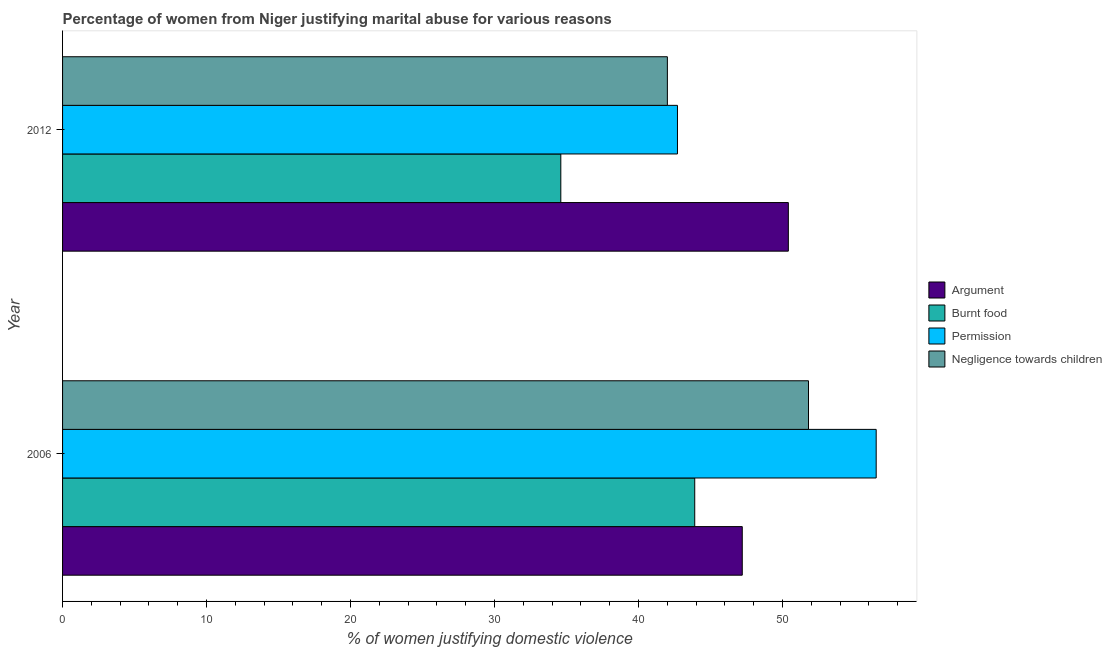How many different coloured bars are there?
Ensure brevity in your answer.  4. How many groups of bars are there?
Provide a short and direct response. 2. Are the number of bars per tick equal to the number of legend labels?
Your answer should be compact. Yes. What is the label of the 1st group of bars from the top?
Your response must be concise. 2012. What is the percentage of women justifying abuse for showing negligence towards children in 2006?
Your answer should be compact. 51.8. Across all years, what is the maximum percentage of women justifying abuse for going without permission?
Provide a succinct answer. 56.5. Across all years, what is the minimum percentage of women justifying abuse for going without permission?
Provide a short and direct response. 42.7. In which year was the percentage of women justifying abuse in the case of an argument maximum?
Ensure brevity in your answer.  2012. What is the total percentage of women justifying abuse for showing negligence towards children in the graph?
Provide a succinct answer. 93.8. What is the difference between the percentage of women justifying abuse for going without permission in 2006 and that in 2012?
Your answer should be very brief. 13.8. What is the difference between the percentage of women justifying abuse for showing negligence towards children in 2006 and the percentage of women justifying abuse for going without permission in 2012?
Ensure brevity in your answer.  9.1. What is the average percentage of women justifying abuse for burning food per year?
Give a very brief answer. 39.25. What is the ratio of the percentage of women justifying abuse for showing negligence towards children in 2006 to that in 2012?
Offer a terse response. 1.23. Is the percentage of women justifying abuse for burning food in 2006 less than that in 2012?
Offer a very short reply. No. In how many years, is the percentage of women justifying abuse for going without permission greater than the average percentage of women justifying abuse for going without permission taken over all years?
Provide a succinct answer. 1. Is it the case that in every year, the sum of the percentage of women justifying abuse for burning food and percentage of women justifying abuse in the case of an argument is greater than the sum of percentage of women justifying abuse for showing negligence towards children and percentage of women justifying abuse for going without permission?
Give a very brief answer. No. What does the 4th bar from the top in 2006 represents?
Your answer should be compact. Argument. What does the 2nd bar from the bottom in 2006 represents?
Provide a succinct answer. Burnt food. How many years are there in the graph?
Your answer should be very brief. 2. What is the difference between two consecutive major ticks on the X-axis?
Offer a terse response. 10. Are the values on the major ticks of X-axis written in scientific E-notation?
Offer a very short reply. No. Does the graph contain any zero values?
Offer a very short reply. No. Does the graph contain grids?
Make the answer very short. No. How many legend labels are there?
Give a very brief answer. 4. What is the title of the graph?
Make the answer very short. Percentage of women from Niger justifying marital abuse for various reasons. What is the label or title of the X-axis?
Offer a terse response. % of women justifying domestic violence. What is the % of women justifying domestic violence of Argument in 2006?
Give a very brief answer. 47.2. What is the % of women justifying domestic violence in Burnt food in 2006?
Your response must be concise. 43.9. What is the % of women justifying domestic violence in Permission in 2006?
Your response must be concise. 56.5. What is the % of women justifying domestic violence of Negligence towards children in 2006?
Make the answer very short. 51.8. What is the % of women justifying domestic violence in Argument in 2012?
Your response must be concise. 50.4. What is the % of women justifying domestic violence in Burnt food in 2012?
Your response must be concise. 34.6. What is the % of women justifying domestic violence in Permission in 2012?
Offer a very short reply. 42.7. What is the % of women justifying domestic violence of Negligence towards children in 2012?
Give a very brief answer. 42. Across all years, what is the maximum % of women justifying domestic violence in Argument?
Keep it short and to the point. 50.4. Across all years, what is the maximum % of women justifying domestic violence in Burnt food?
Provide a short and direct response. 43.9. Across all years, what is the maximum % of women justifying domestic violence of Permission?
Your answer should be very brief. 56.5. Across all years, what is the maximum % of women justifying domestic violence in Negligence towards children?
Your response must be concise. 51.8. Across all years, what is the minimum % of women justifying domestic violence of Argument?
Your answer should be very brief. 47.2. Across all years, what is the minimum % of women justifying domestic violence in Burnt food?
Give a very brief answer. 34.6. Across all years, what is the minimum % of women justifying domestic violence in Permission?
Make the answer very short. 42.7. What is the total % of women justifying domestic violence in Argument in the graph?
Your answer should be very brief. 97.6. What is the total % of women justifying domestic violence of Burnt food in the graph?
Your answer should be compact. 78.5. What is the total % of women justifying domestic violence of Permission in the graph?
Make the answer very short. 99.2. What is the total % of women justifying domestic violence in Negligence towards children in the graph?
Your response must be concise. 93.8. What is the difference between the % of women justifying domestic violence of Permission in 2006 and that in 2012?
Make the answer very short. 13.8. What is the difference between the % of women justifying domestic violence of Negligence towards children in 2006 and that in 2012?
Your answer should be compact. 9.8. What is the difference between the % of women justifying domestic violence in Argument in 2006 and the % of women justifying domestic violence in Permission in 2012?
Offer a terse response. 4.5. What is the difference between the % of women justifying domestic violence of Argument in 2006 and the % of women justifying domestic violence of Negligence towards children in 2012?
Your answer should be compact. 5.2. What is the difference between the % of women justifying domestic violence of Burnt food in 2006 and the % of women justifying domestic violence of Negligence towards children in 2012?
Make the answer very short. 1.9. What is the average % of women justifying domestic violence of Argument per year?
Make the answer very short. 48.8. What is the average % of women justifying domestic violence of Burnt food per year?
Provide a succinct answer. 39.25. What is the average % of women justifying domestic violence of Permission per year?
Offer a terse response. 49.6. What is the average % of women justifying domestic violence of Negligence towards children per year?
Your answer should be very brief. 46.9. In the year 2006, what is the difference between the % of women justifying domestic violence of Argument and % of women justifying domestic violence of Negligence towards children?
Offer a terse response. -4.6. In the year 2006, what is the difference between the % of women justifying domestic violence in Burnt food and % of women justifying domestic violence in Permission?
Your answer should be very brief. -12.6. In the year 2006, what is the difference between the % of women justifying domestic violence of Permission and % of women justifying domestic violence of Negligence towards children?
Give a very brief answer. 4.7. In the year 2012, what is the difference between the % of women justifying domestic violence in Argument and % of women justifying domestic violence in Negligence towards children?
Ensure brevity in your answer.  8.4. In the year 2012, what is the difference between the % of women justifying domestic violence of Burnt food and % of women justifying domestic violence of Permission?
Provide a short and direct response. -8.1. In the year 2012, what is the difference between the % of women justifying domestic violence in Burnt food and % of women justifying domestic violence in Negligence towards children?
Offer a very short reply. -7.4. What is the ratio of the % of women justifying domestic violence of Argument in 2006 to that in 2012?
Your answer should be very brief. 0.94. What is the ratio of the % of women justifying domestic violence of Burnt food in 2006 to that in 2012?
Ensure brevity in your answer.  1.27. What is the ratio of the % of women justifying domestic violence in Permission in 2006 to that in 2012?
Your answer should be very brief. 1.32. What is the ratio of the % of women justifying domestic violence in Negligence towards children in 2006 to that in 2012?
Your answer should be compact. 1.23. What is the difference between the highest and the second highest % of women justifying domestic violence in Burnt food?
Give a very brief answer. 9.3. What is the difference between the highest and the second highest % of women justifying domestic violence of Negligence towards children?
Provide a short and direct response. 9.8. What is the difference between the highest and the lowest % of women justifying domestic violence of Argument?
Provide a succinct answer. 3.2. What is the difference between the highest and the lowest % of women justifying domestic violence in Burnt food?
Offer a terse response. 9.3. What is the difference between the highest and the lowest % of women justifying domestic violence in Permission?
Your answer should be very brief. 13.8. What is the difference between the highest and the lowest % of women justifying domestic violence in Negligence towards children?
Ensure brevity in your answer.  9.8. 